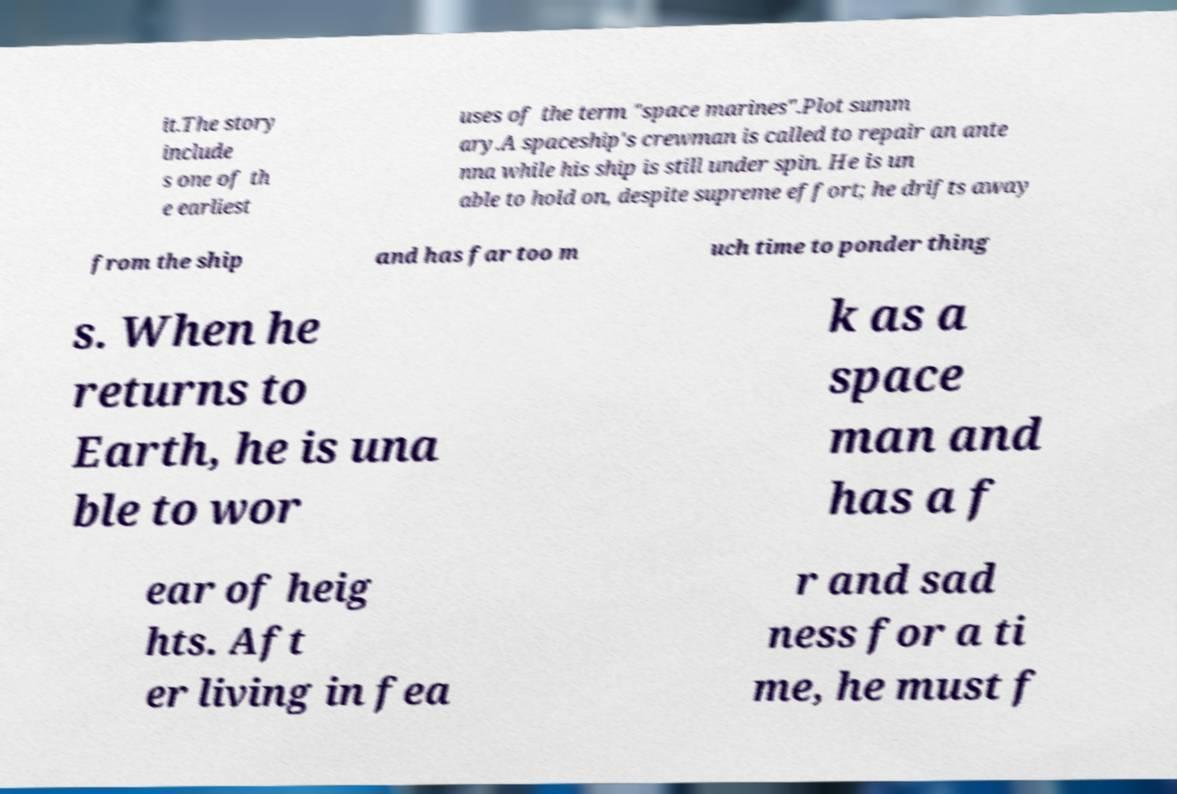Can you read and provide the text displayed in the image?This photo seems to have some interesting text. Can you extract and type it out for me? it.The story include s one of th e earliest uses of the term "space marines".Plot summ ary.A spaceship's crewman is called to repair an ante nna while his ship is still under spin. He is un able to hold on, despite supreme effort; he drifts away from the ship and has far too m uch time to ponder thing s. When he returns to Earth, he is una ble to wor k as a space man and has a f ear of heig hts. Aft er living in fea r and sad ness for a ti me, he must f 